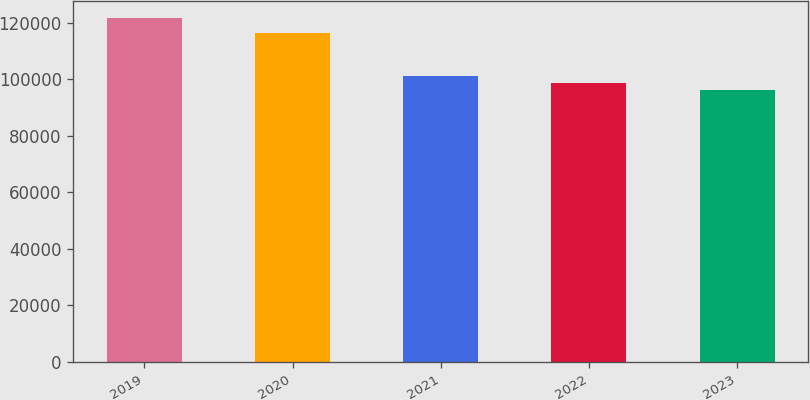<chart> <loc_0><loc_0><loc_500><loc_500><bar_chart><fcel>2019<fcel>2020<fcel>2021<fcel>2022<fcel>2023<nl><fcel>121606<fcel>116341<fcel>101130<fcel>98570.5<fcel>96011<nl></chart> 